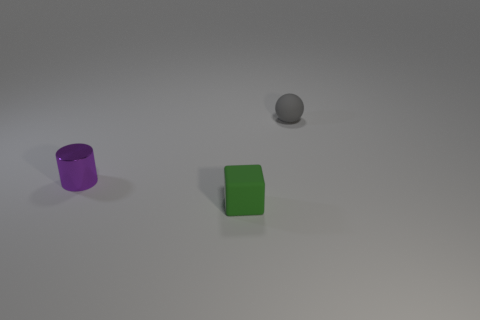There is a small gray rubber object; what shape is it?
Your answer should be very brief. Sphere. Is there any other thing that has the same color as the matte cube?
Provide a short and direct response. No. There is a matte object on the left side of the tiny sphere; is its size the same as the object that is behind the metallic object?
Make the answer very short. Yes. What shape is the tiny rubber object on the right side of the tiny rubber thing that is in front of the gray object?
Make the answer very short. Sphere. Does the purple thing have the same size as the object behind the tiny cylinder?
Provide a succinct answer. Yes. How big is the matte thing in front of the rubber object behind the tiny rubber thing that is left of the gray rubber sphere?
Provide a succinct answer. Small. What number of objects are small objects that are to the left of the tiny gray matte object or small gray matte objects?
Offer a terse response. 3. What number of small gray balls are in front of the tiny matte object that is in front of the rubber sphere?
Your answer should be compact. 0. Are there more tiny gray objects in front of the sphere than green things?
Make the answer very short. No. What is the size of the thing that is both in front of the small rubber ball and behind the small green object?
Your answer should be very brief. Small. 